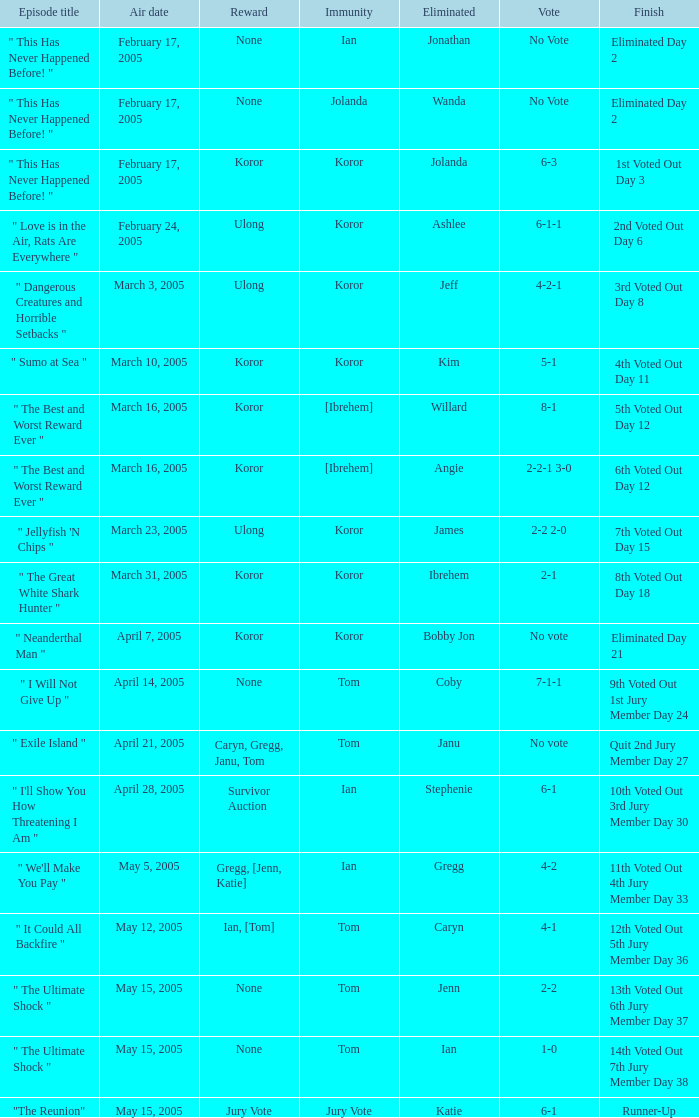Give me the full table as a dictionary. {'header': ['Episode title', 'Air date', 'Reward', 'Immunity', 'Eliminated', 'Vote', 'Finish'], 'rows': [['" This Has Never Happened Before! "', 'February 17, 2005', 'None', 'Ian', 'Jonathan', 'No Vote', 'Eliminated Day 2'], ['" This Has Never Happened Before! "', 'February 17, 2005', 'None', 'Jolanda', 'Wanda', 'No Vote', 'Eliminated Day 2'], ['" This Has Never Happened Before! "', 'February 17, 2005', 'Koror', 'Koror', 'Jolanda', '6-3', '1st Voted Out Day 3'], ['" Love is in the Air, Rats Are Everywhere "', 'February 24, 2005', 'Ulong', 'Koror', 'Ashlee', '6-1-1', '2nd Voted Out Day 6'], ['" Dangerous Creatures and Horrible Setbacks "', 'March 3, 2005', 'Ulong', 'Koror', 'Jeff', '4-2-1', '3rd Voted Out Day 8'], ['" Sumo at Sea "', 'March 10, 2005', 'Koror', 'Koror', 'Kim', '5-1', '4th Voted Out Day 11'], ['" The Best and Worst Reward Ever "', 'March 16, 2005', 'Koror', '[Ibrehem]', 'Willard', '8-1', '5th Voted Out Day 12'], ['" The Best and Worst Reward Ever "', 'March 16, 2005', 'Koror', '[Ibrehem]', 'Angie', '2-2-1 3-0', '6th Voted Out Day 12'], ['" Jellyfish \'N Chips "', 'March 23, 2005', 'Ulong', 'Koror', 'James', '2-2 2-0', '7th Voted Out Day 15'], ['" The Great White Shark Hunter "', 'March 31, 2005', 'Koror', 'Koror', 'Ibrehem', '2-1', '8th Voted Out Day 18'], ['" Neanderthal Man "', 'April 7, 2005', 'Koror', 'Koror', 'Bobby Jon', 'No vote', 'Eliminated Day 21'], ['" I Will Not Give Up "', 'April 14, 2005', 'None', 'Tom', 'Coby', '7-1-1', '9th Voted Out 1st Jury Member Day 24'], ['" Exile Island "', 'April 21, 2005', 'Caryn, Gregg, Janu, Tom', 'Tom', 'Janu', 'No vote', 'Quit 2nd Jury Member Day 27'], ['" I\'ll Show You How Threatening I Am "', 'April 28, 2005', 'Survivor Auction', 'Ian', 'Stephenie', '6-1', '10th Voted Out 3rd Jury Member Day 30'], ['" We\'ll Make You Pay "', 'May 5, 2005', 'Gregg, [Jenn, Katie]', 'Ian', 'Gregg', '4-2', '11th Voted Out 4th Jury Member Day 33'], ['" It Could All Backfire "', 'May 12, 2005', 'Ian, [Tom]', 'Tom', 'Caryn', '4-1', '12th Voted Out 5th Jury Member Day 36'], ['" The Ultimate Shock "', 'May 15, 2005', 'None', 'Tom', 'Jenn', '2-2', '13th Voted Out 6th Jury Member Day 37'], ['" The Ultimate Shock "', 'May 15, 2005', 'None', 'Tom', 'Ian', '1-0', '14th Voted Out 7th Jury Member Day 38'], ['"The Reunion"', 'May 15, 2005', 'Jury Vote', 'Jury Vote', 'Katie', '6-1', 'Runner-Up']]} What was the vote tally on the episode aired May 5, 2005? 4-2. 